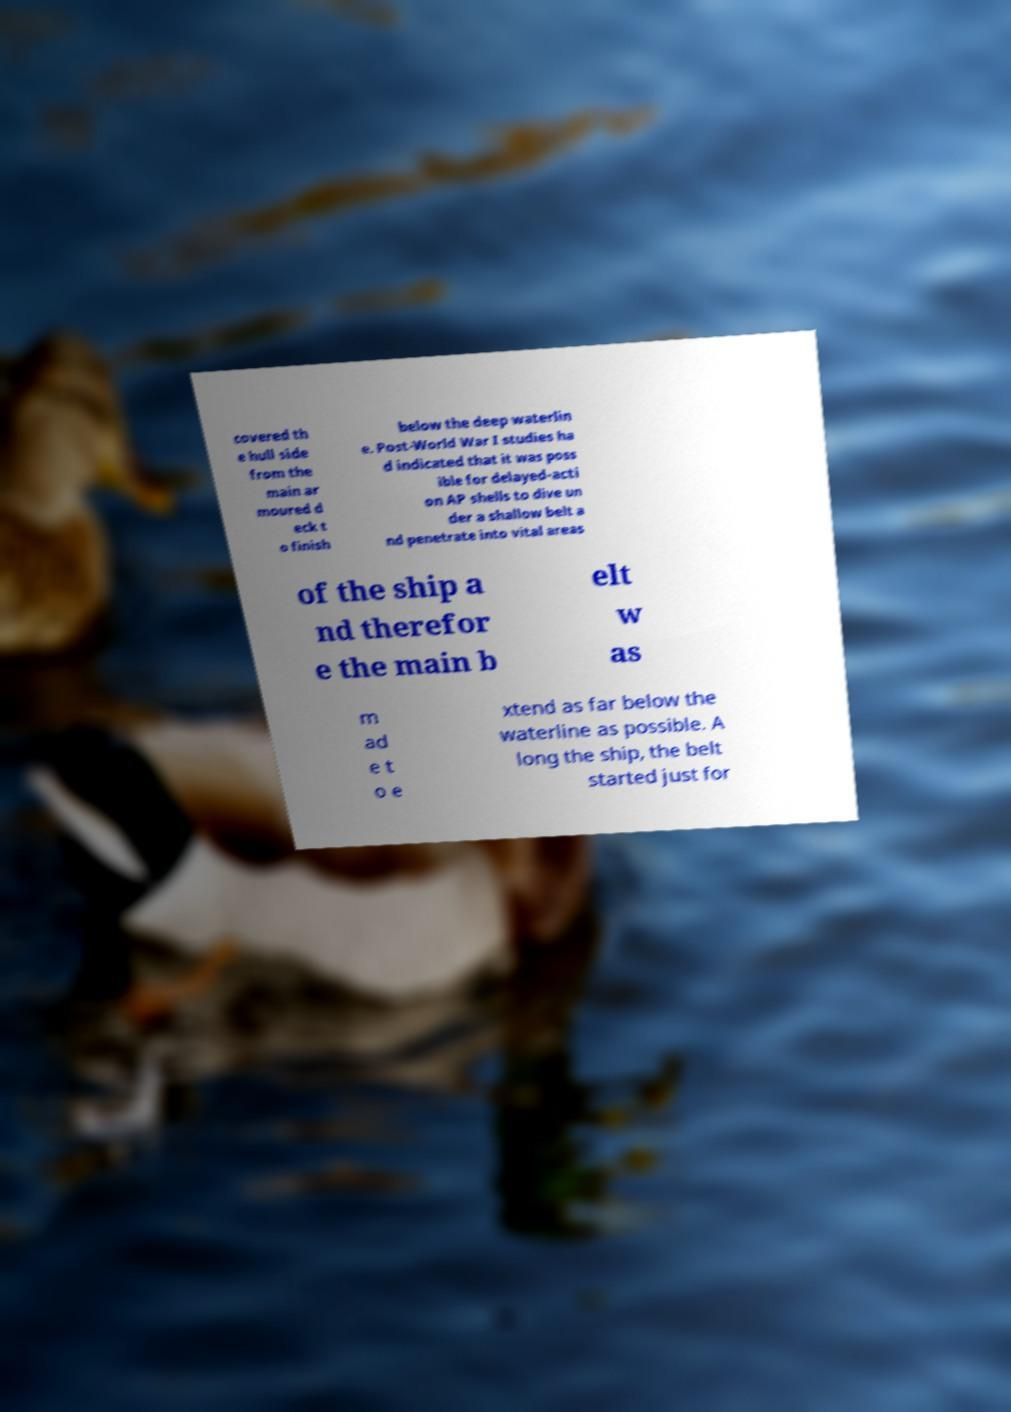Please identify and transcribe the text found in this image. covered th e hull side from the main ar moured d eck t o finish below the deep waterlin e. Post-World War I studies ha d indicated that it was poss ible for delayed-acti on AP shells to dive un der a shallow belt a nd penetrate into vital areas of the ship a nd therefor e the main b elt w as m ad e t o e xtend as far below the waterline as possible. A long the ship, the belt started just for 